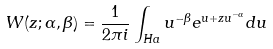Convert formula to latex. <formula><loc_0><loc_0><loc_500><loc_500>W ( z ; \alpha , \beta ) = \frac { 1 } { 2 \pi i } \int _ { H a } u ^ { - \beta } e ^ { u + z u ^ { - \alpha } } d u</formula> 